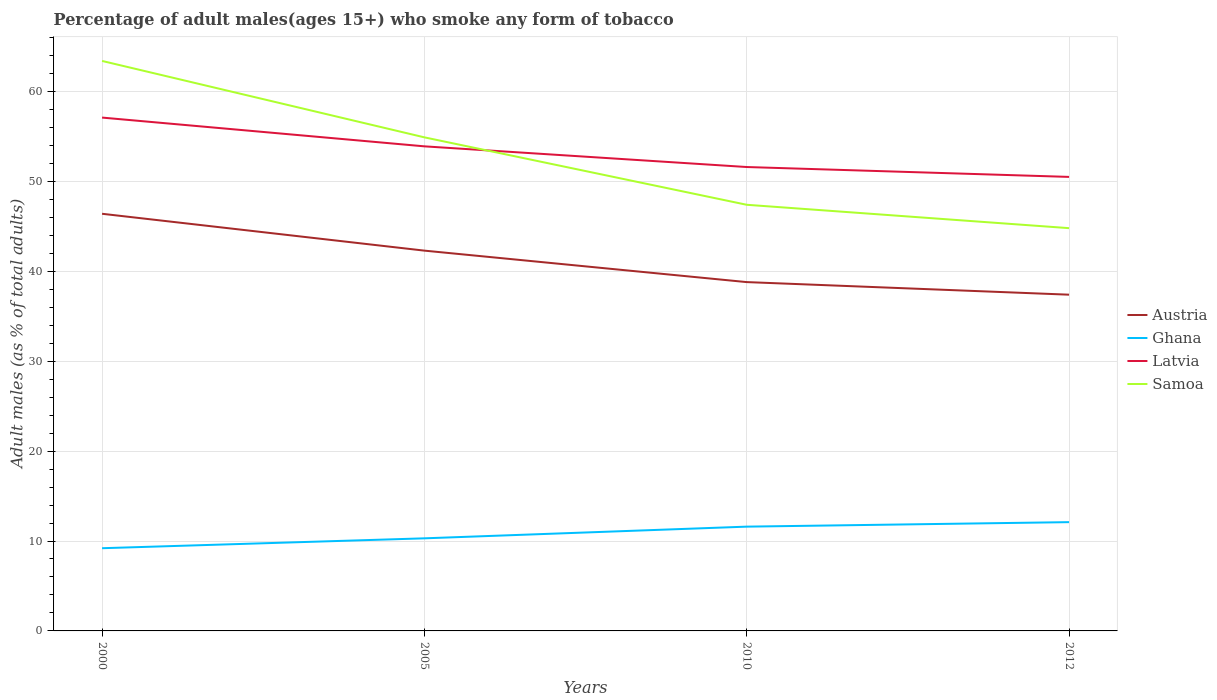Does the line corresponding to Ghana intersect with the line corresponding to Samoa?
Keep it short and to the point. No. Is the number of lines equal to the number of legend labels?
Offer a terse response. Yes. Across all years, what is the maximum percentage of adult males who smoke in Austria?
Your response must be concise. 37.4. In which year was the percentage of adult males who smoke in Latvia maximum?
Your response must be concise. 2012. What is the total percentage of adult males who smoke in Samoa in the graph?
Ensure brevity in your answer.  2.6. What is the difference between the highest and the lowest percentage of adult males who smoke in Latvia?
Offer a terse response. 2. Is the percentage of adult males who smoke in Austria strictly greater than the percentage of adult males who smoke in Samoa over the years?
Keep it short and to the point. Yes. How many years are there in the graph?
Keep it short and to the point. 4. How are the legend labels stacked?
Offer a very short reply. Vertical. What is the title of the graph?
Provide a short and direct response. Percentage of adult males(ages 15+) who smoke any form of tobacco. Does "Lithuania" appear as one of the legend labels in the graph?
Keep it short and to the point. No. What is the label or title of the X-axis?
Offer a very short reply. Years. What is the label or title of the Y-axis?
Your answer should be compact. Adult males (as % of total adults). What is the Adult males (as % of total adults) of Austria in 2000?
Your response must be concise. 46.4. What is the Adult males (as % of total adults) of Latvia in 2000?
Ensure brevity in your answer.  57.1. What is the Adult males (as % of total adults) in Samoa in 2000?
Offer a terse response. 63.4. What is the Adult males (as % of total adults) in Austria in 2005?
Provide a succinct answer. 42.3. What is the Adult males (as % of total adults) of Ghana in 2005?
Provide a succinct answer. 10.3. What is the Adult males (as % of total adults) of Latvia in 2005?
Provide a succinct answer. 53.9. What is the Adult males (as % of total adults) of Samoa in 2005?
Provide a short and direct response. 54.9. What is the Adult males (as % of total adults) in Austria in 2010?
Provide a short and direct response. 38.8. What is the Adult males (as % of total adults) of Ghana in 2010?
Provide a succinct answer. 11.6. What is the Adult males (as % of total adults) in Latvia in 2010?
Your answer should be compact. 51.6. What is the Adult males (as % of total adults) of Samoa in 2010?
Your answer should be very brief. 47.4. What is the Adult males (as % of total adults) of Austria in 2012?
Provide a succinct answer. 37.4. What is the Adult males (as % of total adults) of Ghana in 2012?
Ensure brevity in your answer.  12.1. What is the Adult males (as % of total adults) in Latvia in 2012?
Make the answer very short. 50.5. What is the Adult males (as % of total adults) in Samoa in 2012?
Your answer should be very brief. 44.8. Across all years, what is the maximum Adult males (as % of total adults) of Austria?
Provide a succinct answer. 46.4. Across all years, what is the maximum Adult males (as % of total adults) in Ghana?
Your answer should be compact. 12.1. Across all years, what is the maximum Adult males (as % of total adults) in Latvia?
Offer a very short reply. 57.1. Across all years, what is the maximum Adult males (as % of total adults) in Samoa?
Ensure brevity in your answer.  63.4. Across all years, what is the minimum Adult males (as % of total adults) in Austria?
Keep it short and to the point. 37.4. Across all years, what is the minimum Adult males (as % of total adults) of Latvia?
Your answer should be very brief. 50.5. Across all years, what is the minimum Adult males (as % of total adults) of Samoa?
Ensure brevity in your answer.  44.8. What is the total Adult males (as % of total adults) of Austria in the graph?
Make the answer very short. 164.9. What is the total Adult males (as % of total adults) in Ghana in the graph?
Keep it short and to the point. 43.2. What is the total Adult males (as % of total adults) in Latvia in the graph?
Your response must be concise. 213.1. What is the total Adult males (as % of total adults) of Samoa in the graph?
Offer a terse response. 210.5. What is the difference between the Adult males (as % of total adults) of Samoa in 2000 and that in 2005?
Provide a short and direct response. 8.5. What is the difference between the Adult males (as % of total adults) in Latvia in 2000 and that in 2010?
Your answer should be very brief. 5.5. What is the difference between the Adult males (as % of total adults) of Samoa in 2000 and that in 2010?
Provide a short and direct response. 16. What is the difference between the Adult males (as % of total adults) of Austria in 2000 and that in 2012?
Make the answer very short. 9. What is the difference between the Adult males (as % of total adults) in Latvia in 2000 and that in 2012?
Your response must be concise. 6.6. What is the difference between the Adult males (as % of total adults) of Samoa in 2000 and that in 2012?
Offer a very short reply. 18.6. What is the difference between the Adult males (as % of total adults) in Austria in 2005 and that in 2010?
Your answer should be very brief. 3.5. What is the difference between the Adult males (as % of total adults) in Ghana in 2005 and that in 2010?
Your answer should be compact. -1.3. What is the difference between the Adult males (as % of total adults) in Latvia in 2005 and that in 2010?
Offer a very short reply. 2.3. What is the difference between the Adult males (as % of total adults) in Samoa in 2005 and that in 2010?
Your answer should be compact. 7.5. What is the difference between the Adult males (as % of total adults) of Austria in 2005 and that in 2012?
Offer a terse response. 4.9. What is the difference between the Adult males (as % of total adults) in Latvia in 2005 and that in 2012?
Your response must be concise. 3.4. What is the difference between the Adult males (as % of total adults) in Samoa in 2005 and that in 2012?
Keep it short and to the point. 10.1. What is the difference between the Adult males (as % of total adults) of Ghana in 2010 and that in 2012?
Make the answer very short. -0.5. What is the difference between the Adult males (as % of total adults) in Austria in 2000 and the Adult males (as % of total adults) in Ghana in 2005?
Provide a succinct answer. 36.1. What is the difference between the Adult males (as % of total adults) in Austria in 2000 and the Adult males (as % of total adults) in Latvia in 2005?
Give a very brief answer. -7.5. What is the difference between the Adult males (as % of total adults) in Austria in 2000 and the Adult males (as % of total adults) in Samoa in 2005?
Provide a short and direct response. -8.5. What is the difference between the Adult males (as % of total adults) in Ghana in 2000 and the Adult males (as % of total adults) in Latvia in 2005?
Your answer should be very brief. -44.7. What is the difference between the Adult males (as % of total adults) of Ghana in 2000 and the Adult males (as % of total adults) of Samoa in 2005?
Provide a succinct answer. -45.7. What is the difference between the Adult males (as % of total adults) of Austria in 2000 and the Adult males (as % of total adults) of Ghana in 2010?
Make the answer very short. 34.8. What is the difference between the Adult males (as % of total adults) of Austria in 2000 and the Adult males (as % of total adults) of Samoa in 2010?
Offer a very short reply. -1. What is the difference between the Adult males (as % of total adults) of Ghana in 2000 and the Adult males (as % of total adults) of Latvia in 2010?
Provide a short and direct response. -42.4. What is the difference between the Adult males (as % of total adults) of Ghana in 2000 and the Adult males (as % of total adults) of Samoa in 2010?
Your response must be concise. -38.2. What is the difference between the Adult males (as % of total adults) in Austria in 2000 and the Adult males (as % of total adults) in Ghana in 2012?
Your answer should be very brief. 34.3. What is the difference between the Adult males (as % of total adults) in Austria in 2000 and the Adult males (as % of total adults) in Latvia in 2012?
Provide a short and direct response. -4.1. What is the difference between the Adult males (as % of total adults) of Ghana in 2000 and the Adult males (as % of total adults) of Latvia in 2012?
Offer a very short reply. -41.3. What is the difference between the Adult males (as % of total adults) of Ghana in 2000 and the Adult males (as % of total adults) of Samoa in 2012?
Offer a very short reply. -35.6. What is the difference between the Adult males (as % of total adults) in Austria in 2005 and the Adult males (as % of total adults) in Ghana in 2010?
Offer a very short reply. 30.7. What is the difference between the Adult males (as % of total adults) of Ghana in 2005 and the Adult males (as % of total adults) of Latvia in 2010?
Offer a very short reply. -41.3. What is the difference between the Adult males (as % of total adults) of Ghana in 2005 and the Adult males (as % of total adults) of Samoa in 2010?
Your response must be concise. -37.1. What is the difference between the Adult males (as % of total adults) of Latvia in 2005 and the Adult males (as % of total adults) of Samoa in 2010?
Offer a very short reply. 6.5. What is the difference between the Adult males (as % of total adults) of Austria in 2005 and the Adult males (as % of total adults) of Ghana in 2012?
Ensure brevity in your answer.  30.2. What is the difference between the Adult males (as % of total adults) in Ghana in 2005 and the Adult males (as % of total adults) in Latvia in 2012?
Provide a succinct answer. -40.2. What is the difference between the Adult males (as % of total adults) in Ghana in 2005 and the Adult males (as % of total adults) in Samoa in 2012?
Your response must be concise. -34.5. What is the difference between the Adult males (as % of total adults) of Austria in 2010 and the Adult males (as % of total adults) of Ghana in 2012?
Ensure brevity in your answer.  26.7. What is the difference between the Adult males (as % of total adults) in Austria in 2010 and the Adult males (as % of total adults) in Latvia in 2012?
Your response must be concise. -11.7. What is the difference between the Adult males (as % of total adults) in Austria in 2010 and the Adult males (as % of total adults) in Samoa in 2012?
Offer a terse response. -6. What is the difference between the Adult males (as % of total adults) in Ghana in 2010 and the Adult males (as % of total adults) in Latvia in 2012?
Offer a terse response. -38.9. What is the difference between the Adult males (as % of total adults) in Ghana in 2010 and the Adult males (as % of total adults) in Samoa in 2012?
Your answer should be compact. -33.2. What is the average Adult males (as % of total adults) in Austria per year?
Offer a very short reply. 41.23. What is the average Adult males (as % of total adults) of Ghana per year?
Offer a terse response. 10.8. What is the average Adult males (as % of total adults) of Latvia per year?
Ensure brevity in your answer.  53.27. What is the average Adult males (as % of total adults) of Samoa per year?
Ensure brevity in your answer.  52.62. In the year 2000, what is the difference between the Adult males (as % of total adults) in Austria and Adult males (as % of total adults) in Ghana?
Offer a very short reply. 37.2. In the year 2000, what is the difference between the Adult males (as % of total adults) in Austria and Adult males (as % of total adults) in Latvia?
Keep it short and to the point. -10.7. In the year 2000, what is the difference between the Adult males (as % of total adults) in Austria and Adult males (as % of total adults) in Samoa?
Your response must be concise. -17. In the year 2000, what is the difference between the Adult males (as % of total adults) in Ghana and Adult males (as % of total adults) in Latvia?
Your answer should be very brief. -47.9. In the year 2000, what is the difference between the Adult males (as % of total adults) in Ghana and Adult males (as % of total adults) in Samoa?
Give a very brief answer. -54.2. In the year 2005, what is the difference between the Adult males (as % of total adults) in Austria and Adult males (as % of total adults) in Ghana?
Provide a succinct answer. 32. In the year 2005, what is the difference between the Adult males (as % of total adults) in Austria and Adult males (as % of total adults) in Latvia?
Offer a very short reply. -11.6. In the year 2005, what is the difference between the Adult males (as % of total adults) in Austria and Adult males (as % of total adults) in Samoa?
Keep it short and to the point. -12.6. In the year 2005, what is the difference between the Adult males (as % of total adults) in Ghana and Adult males (as % of total adults) in Latvia?
Provide a succinct answer. -43.6. In the year 2005, what is the difference between the Adult males (as % of total adults) in Ghana and Adult males (as % of total adults) in Samoa?
Your answer should be compact. -44.6. In the year 2010, what is the difference between the Adult males (as % of total adults) in Austria and Adult males (as % of total adults) in Ghana?
Keep it short and to the point. 27.2. In the year 2010, what is the difference between the Adult males (as % of total adults) of Austria and Adult males (as % of total adults) of Latvia?
Provide a short and direct response. -12.8. In the year 2010, what is the difference between the Adult males (as % of total adults) in Ghana and Adult males (as % of total adults) in Samoa?
Provide a succinct answer. -35.8. In the year 2010, what is the difference between the Adult males (as % of total adults) of Latvia and Adult males (as % of total adults) of Samoa?
Make the answer very short. 4.2. In the year 2012, what is the difference between the Adult males (as % of total adults) of Austria and Adult males (as % of total adults) of Ghana?
Your response must be concise. 25.3. In the year 2012, what is the difference between the Adult males (as % of total adults) of Austria and Adult males (as % of total adults) of Samoa?
Your answer should be compact. -7.4. In the year 2012, what is the difference between the Adult males (as % of total adults) in Ghana and Adult males (as % of total adults) in Latvia?
Offer a very short reply. -38.4. In the year 2012, what is the difference between the Adult males (as % of total adults) in Ghana and Adult males (as % of total adults) in Samoa?
Your response must be concise. -32.7. In the year 2012, what is the difference between the Adult males (as % of total adults) in Latvia and Adult males (as % of total adults) in Samoa?
Offer a very short reply. 5.7. What is the ratio of the Adult males (as % of total adults) in Austria in 2000 to that in 2005?
Provide a short and direct response. 1.1. What is the ratio of the Adult males (as % of total adults) in Ghana in 2000 to that in 2005?
Your answer should be compact. 0.89. What is the ratio of the Adult males (as % of total adults) in Latvia in 2000 to that in 2005?
Your answer should be compact. 1.06. What is the ratio of the Adult males (as % of total adults) of Samoa in 2000 to that in 2005?
Offer a terse response. 1.15. What is the ratio of the Adult males (as % of total adults) in Austria in 2000 to that in 2010?
Provide a succinct answer. 1.2. What is the ratio of the Adult males (as % of total adults) in Ghana in 2000 to that in 2010?
Give a very brief answer. 0.79. What is the ratio of the Adult males (as % of total adults) in Latvia in 2000 to that in 2010?
Keep it short and to the point. 1.11. What is the ratio of the Adult males (as % of total adults) of Samoa in 2000 to that in 2010?
Keep it short and to the point. 1.34. What is the ratio of the Adult males (as % of total adults) in Austria in 2000 to that in 2012?
Offer a very short reply. 1.24. What is the ratio of the Adult males (as % of total adults) of Ghana in 2000 to that in 2012?
Your response must be concise. 0.76. What is the ratio of the Adult males (as % of total adults) in Latvia in 2000 to that in 2012?
Make the answer very short. 1.13. What is the ratio of the Adult males (as % of total adults) of Samoa in 2000 to that in 2012?
Your response must be concise. 1.42. What is the ratio of the Adult males (as % of total adults) of Austria in 2005 to that in 2010?
Your answer should be compact. 1.09. What is the ratio of the Adult males (as % of total adults) of Ghana in 2005 to that in 2010?
Offer a very short reply. 0.89. What is the ratio of the Adult males (as % of total adults) in Latvia in 2005 to that in 2010?
Your answer should be compact. 1.04. What is the ratio of the Adult males (as % of total adults) in Samoa in 2005 to that in 2010?
Make the answer very short. 1.16. What is the ratio of the Adult males (as % of total adults) in Austria in 2005 to that in 2012?
Offer a terse response. 1.13. What is the ratio of the Adult males (as % of total adults) in Ghana in 2005 to that in 2012?
Make the answer very short. 0.85. What is the ratio of the Adult males (as % of total adults) of Latvia in 2005 to that in 2012?
Give a very brief answer. 1.07. What is the ratio of the Adult males (as % of total adults) in Samoa in 2005 to that in 2012?
Provide a short and direct response. 1.23. What is the ratio of the Adult males (as % of total adults) in Austria in 2010 to that in 2012?
Offer a terse response. 1.04. What is the ratio of the Adult males (as % of total adults) of Ghana in 2010 to that in 2012?
Offer a very short reply. 0.96. What is the ratio of the Adult males (as % of total adults) of Latvia in 2010 to that in 2012?
Your answer should be very brief. 1.02. What is the ratio of the Adult males (as % of total adults) of Samoa in 2010 to that in 2012?
Keep it short and to the point. 1.06. What is the difference between the highest and the second highest Adult males (as % of total adults) in Latvia?
Offer a terse response. 3.2. What is the difference between the highest and the lowest Adult males (as % of total adults) of Ghana?
Your answer should be very brief. 2.9. What is the difference between the highest and the lowest Adult males (as % of total adults) of Latvia?
Keep it short and to the point. 6.6. 